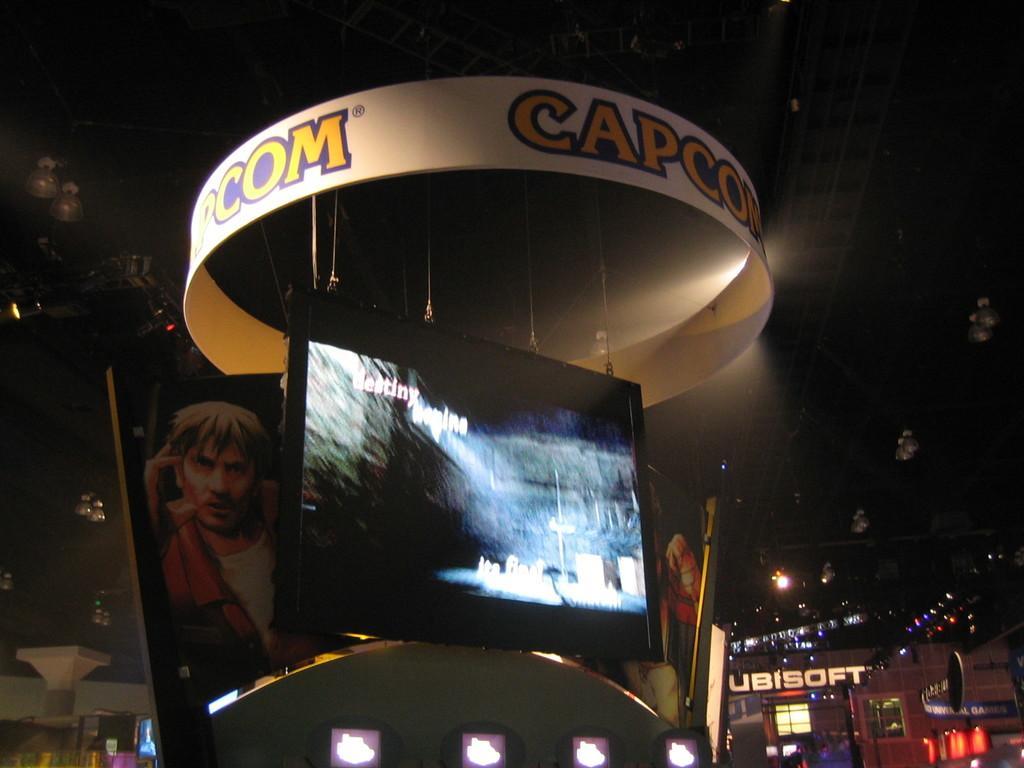Please provide a concise description of this image. In front of the image there is a TV. There are boards with some text and pictures on it. In the background of the image there are display boards, buildings. At the top of the image there are lamps and metal rods. 